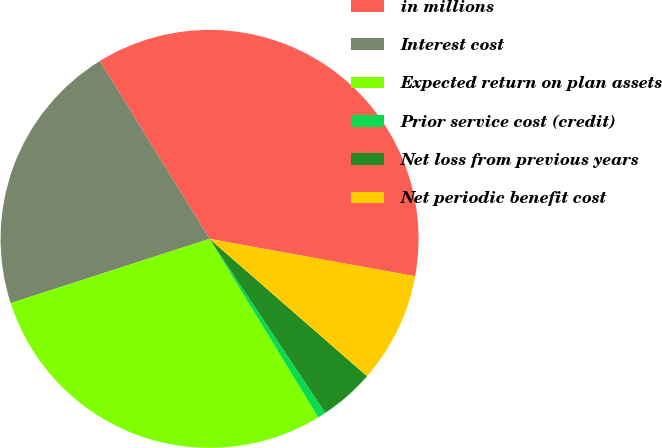Convert chart. <chart><loc_0><loc_0><loc_500><loc_500><pie_chart><fcel>in millions<fcel>Interest cost<fcel>Expected return on plan assets<fcel>Prior service cost (credit)<fcel>Net loss from previous years<fcel>Net periodic benefit cost<nl><fcel>36.66%<fcel>21.18%<fcel>28.73%<fcel>0.64%<fcel>4.24%<fcel>8.55%<nl></chart> 